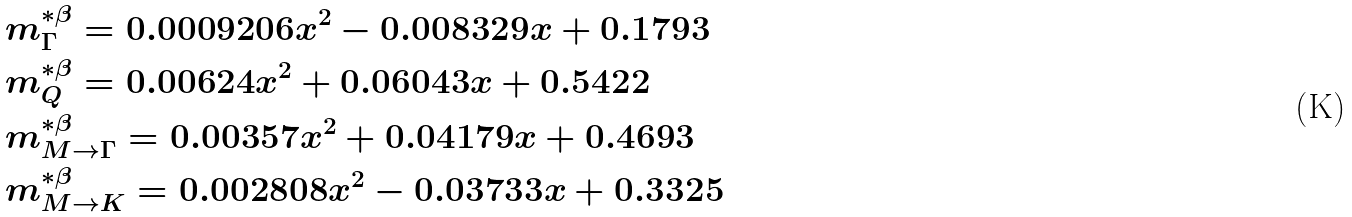<formula> <loc_0><loc_0><loc_500><loc_500>& m ^ { * \beta } _ { \Gamma } = 0 . 0 0 0 9 2 0 6 x ^ { 2 } - 0 . 0 0 8 3 2 9 x + 0 . 1 7 9 3 \\ & m ^ { * \beta } _ { Q } = 0 . 0 0 6 2 4 x ^ { 2 } + 0 . 0 6 0 4 3 x + 0 . 5 4 2 2 \\ & m ^ { * \beta } _ { M \rightarrow \Gamma } = 0 . 0 0 3 5 7 x ^ { 2 } + 0 . 0 4 1 7 9 x + 0 . 4 6 9 3 \\ & m ^ { * \beta } _ { M \rightarrow K } = 0 . 0 0 2 8 0 8 x ^ { 2 } - 0 . 0 3 7 3 3 x + 0 . 3 3 2 5</formula> 